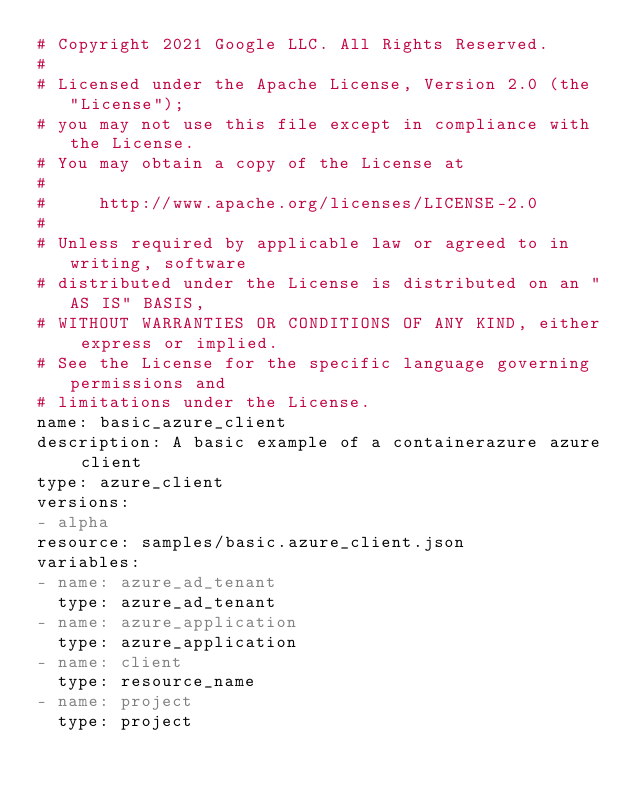<code> <loc_0><loc_0><loc_500><loc_500><_YAML_># Copyright 2021 Google LLC. All Rights Reserved.
# 
# Licensed under the Apache License, Version 2.0 (the "License");
# you may not use this file except in compliance with the License.
# You may obtain a copy of the License at
# 
#     http://www.apache.org/licenses/LICENSE-2.0
# 
# Unless required by applicable law or agreed to in writing, software
# distributed under the License is distributed on an "AS IS" BASIS,
# WITHOUT WARRANTIES OR CONDITIONS OF ANY KIND, either express or implied.
# See the License for the specific language governing permissions and
# limitations under the License.
name: basic_azure_client
description: A basic example of a containerazure azure client
type: azure_client
versions:
- alpha
resource: samples/basic.azure_client.json
variables:
- name: azure_ad_tenant
  type: azure_ad_tenant
- name: azure_application
  type: azure_application
- name: client
  type: resource_name
- name: project
  type: project
</code> 